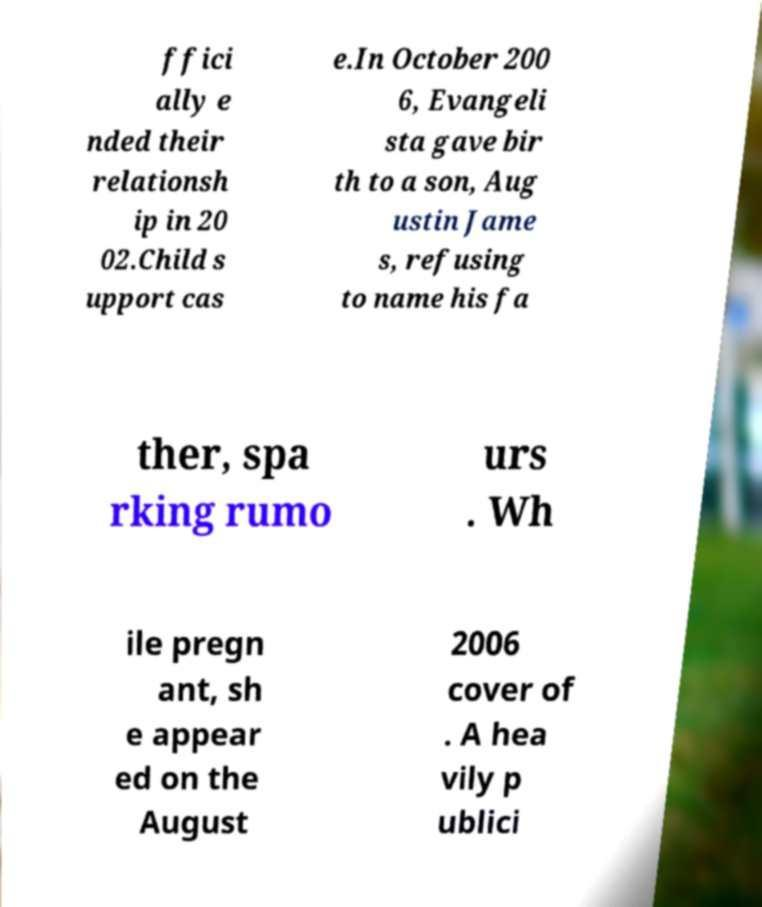Please identify and transcribe the text found in this image. ffici ally e nded their relationsh ip in 20 02.Child s upport cas e.In October 200 6, Evangeli sta gave bir th to a son, Aug ustin Jame s, refusing to name his fa ther, spa rking rumo urs . Wh ile pregn ant, sh e appear ed on the August 2006 cover of . A hea vily p ublici 